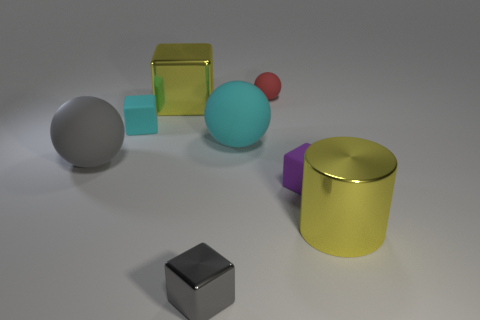What number of matte objects are either big cyan objects or tiny red balls?
Ensure brevity in your answer.  2. There is a shiny thing that is behind the yellow metallic object in front of the large yellow metal thing behind the gray matte object; how big is it?
Ensure brevity in your answer.  Large. There is a matte object that is both to the left of the tiny metallic cube and on the right side of the large gray rubber thing; how big is it?
Offer a very short reply. Small. There is a large shiny thing that is on the left side of the red matte sphere; does it have the same color as the big object that is to the right of the purple thing?
Make the answer very short. Yes. There is a tiny cyan rubber object; what number of red rubber things are on the left side of it?
Your answer should be compact. 0. There is a yellow thing that is behind the yellow metallic object to the right of the tiny red rubber sphere; is there a small purple block in front of it?
Give a very brief answer. Yes. How many yellow spheres have the same size as the cyan matte cube?
Your answer should be compact. 0. What is the material of the tiny block that is in front of the large yellow thing right of the small purple cube?
Provide a succinct answer. Metal. There is a yellow shiny object on the right side of the large matte object that is to the right of the large yellow shiny object that is left of the red matte object; what is its shape?
Give a very brief answer. Cylinder. Is the shape of the large metal thing behind the purple rubber cube the same as the tiny thing that is in front of the purple cube?
Your answer should be compact. Yes. 